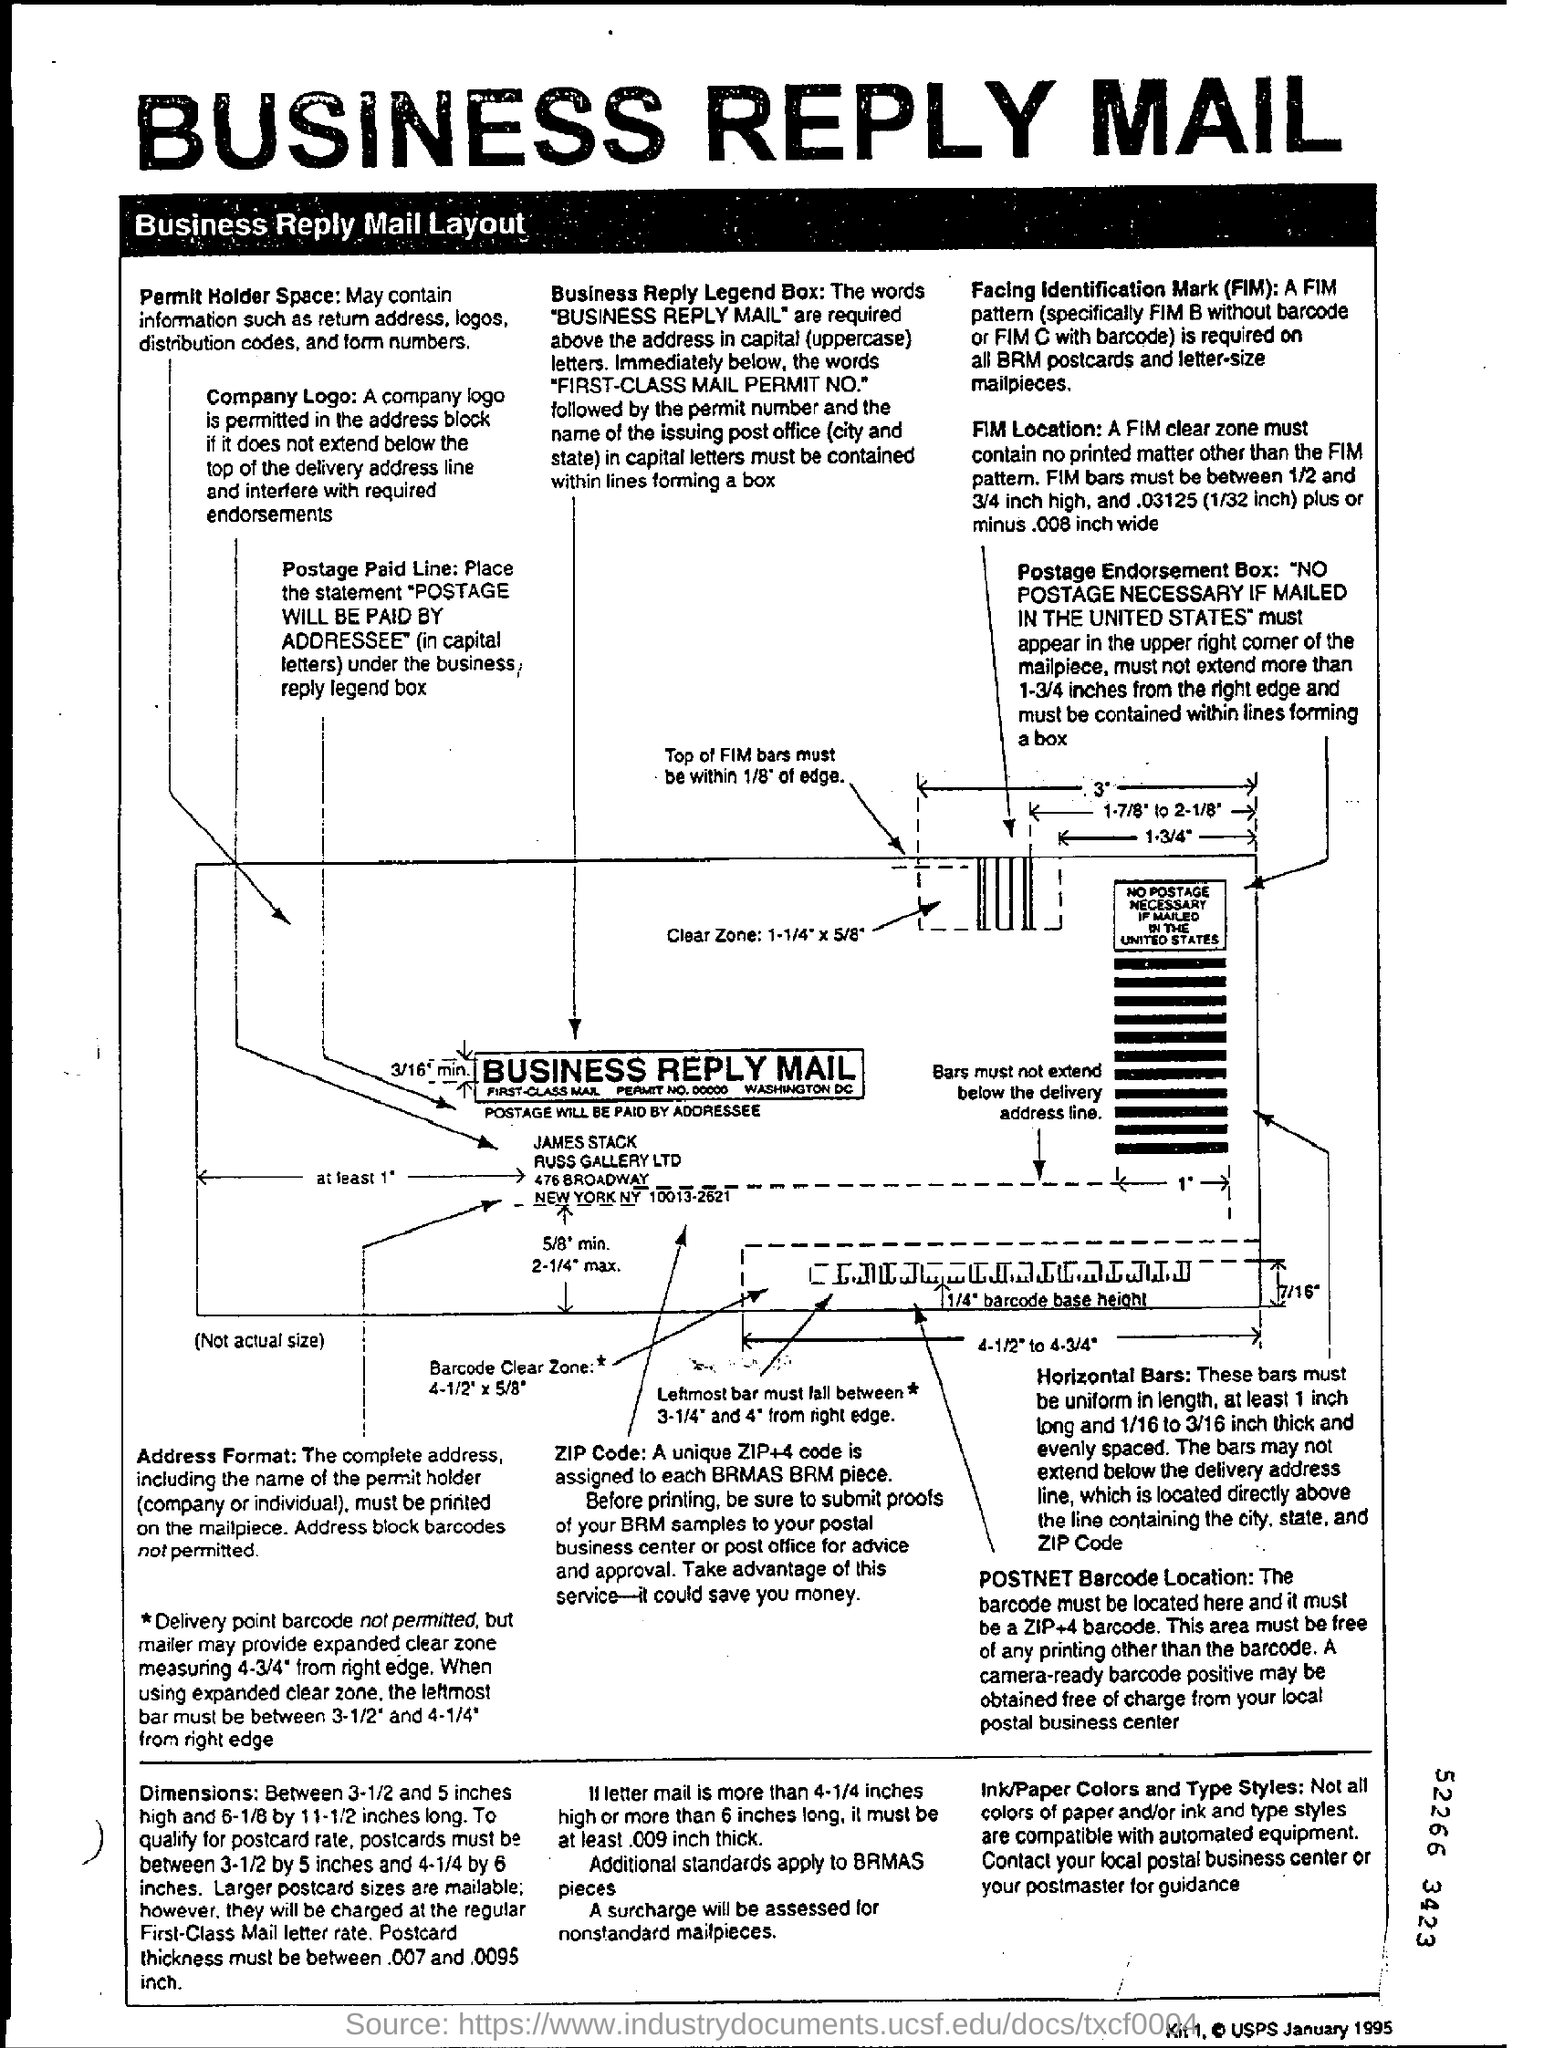Indicate a few pertinent items in this graphic. The heading at the top of the page reads 'Business Reply Mail.' 